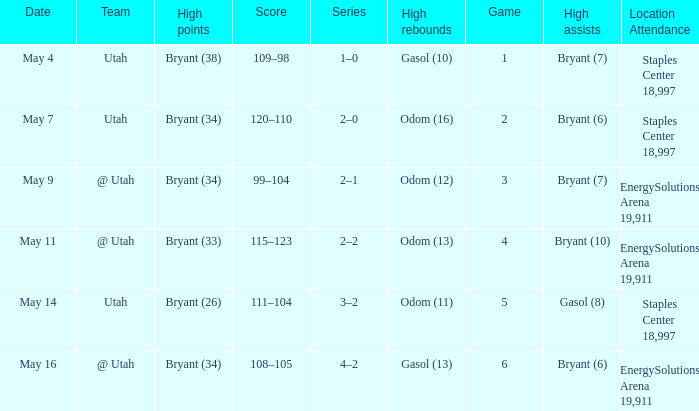What is the High rebounds with a Series with 4–2? Gasol (13). 